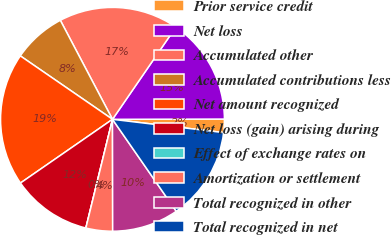Convert chart to OTSL. <chart><loc_0><loc_0><loc_500><loc_500><pie_chart><fcel>Prior service credit<fcel>Net loss<fcel>Accumulated other<fcel>Accumulated contributions less<fcel>Net amount recognized<fcel>Net loss (gain) arising during<fcel>Effect of exchange rates on<fcel>Amortization or settlement<fcel>Total recognized in other<fcel>Total recognized in net<nl><fcel>1.93%<fcel>15.38%<fcel>17.3%<fcel>7.69%<fcel>19.23%<fcel>11.54%<fcel>0.0%<fcel>3.85%<fcel>9.62%<fcel>13.46%<nl></chart> 